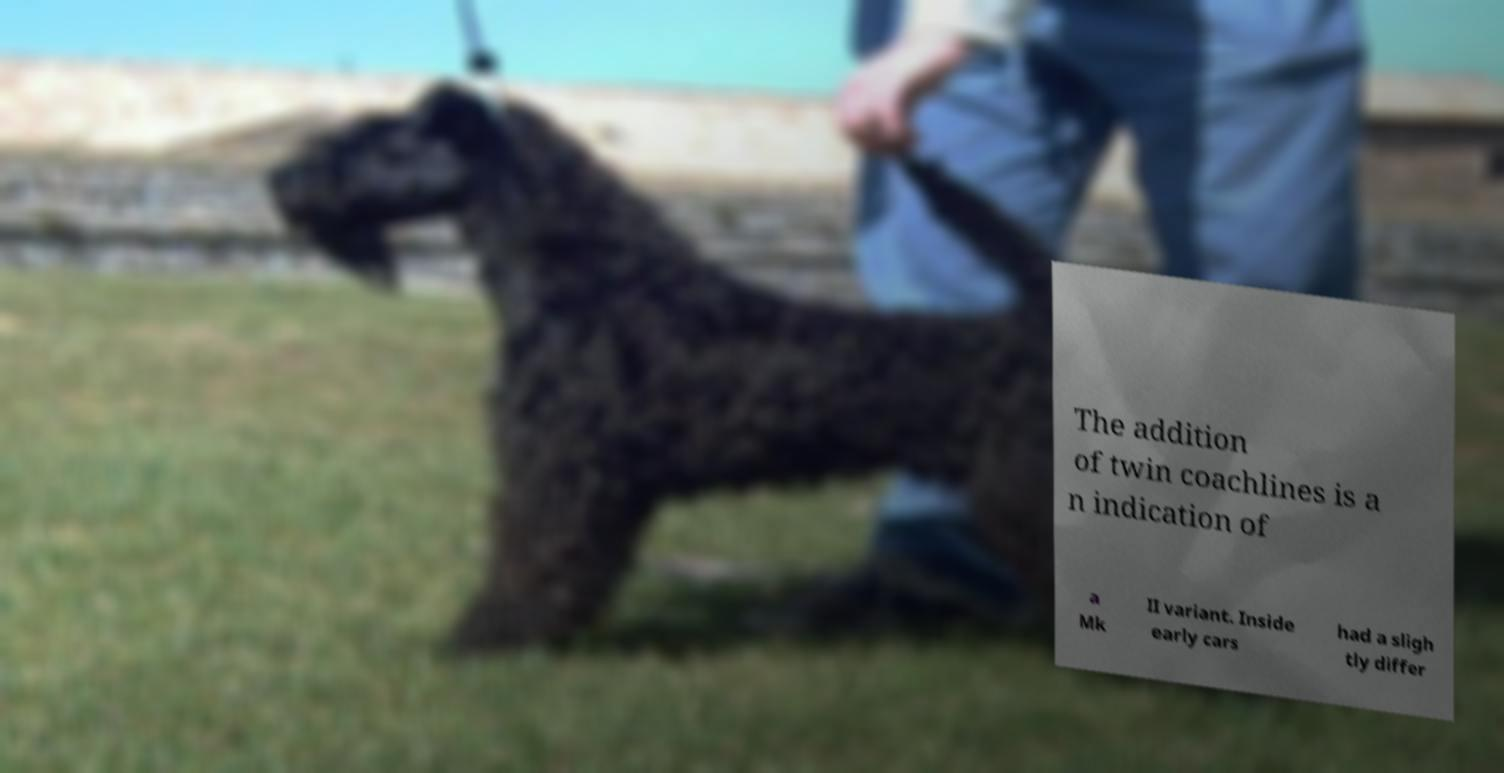Could you assist in decoding the text presented in this image and type it out clearly? The addition of twin coachlines is a n indication of a Mk II variant. Inside early cars had a sligh tly differ 